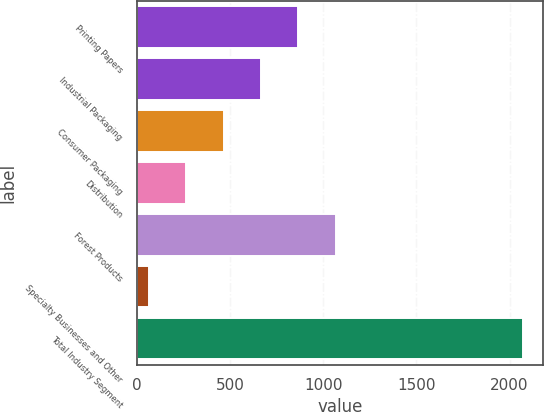<chart> <loc_0><loc_0><loc_500><loc_500><bar_chart><fcel>Printing Papers<fcel>Industrial Packaging<fcel>Consumer Packaging<fcel>Distribution<fcel>Forest Products<fcel>Specialty Businesses and Other<fcel>Total Industry Segment<nl><fcel>866.2<fcel>664.9<fcel>463.6<fcel>262.3<fcel>1067.5<fcel>61<fcel>2074<nl></chart> 